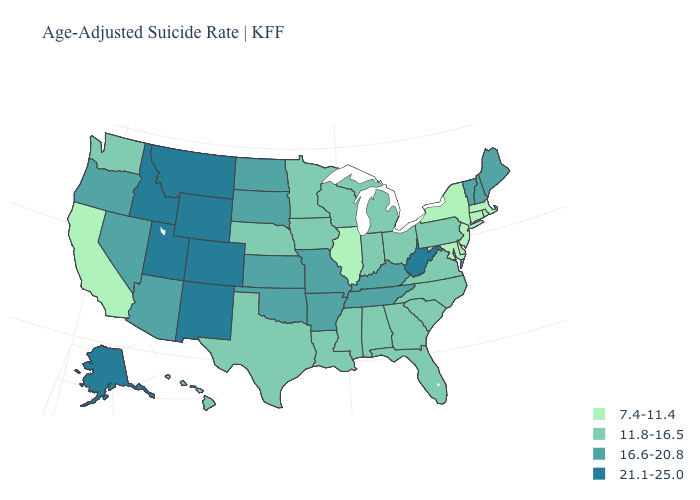Which states have the highest value in the USA?
Keep it brief. Alaska, Colorado, Idaho, Montana, New Mexico, Utah, West Virginia, Wyoming. How many symbols are there in the legend?
Short answer required. 4. What is the value of Mississippi?
Give a very brief answer. 11.8-16.5. Name the states that have a value in the range 16.6-20.8?
Write a very short answer. Arizona, Arkansas, Kansas, Kentucky, Maine, Missouri, Nevada, New Hampshire, North Dakota, Oklahoma, Oregon, South Dakota, Tennessee, Vermont. Name the states that have a value in the range 11.8-16.5?
Be succinct. Alabama, Florida, Georgia, Hawaii, Indiana, Iowa, Louisiana, Michigan, Minnesota, Mississippi, Nebraska, North Carolina, Ohio, Pennsylvania, South Carolina, Texas, Virginia, Washington, Wisconsin. Does the first symbol in the legend represent the smallest category?
Concise answer only. Yes. Does Michigan have the highest value in the MidWest?
Give a very brief answer. No. Does Arizona have the highest value in the West?
Answer briefly. No. Does Illinois have the highest value in the USA?
Keep it brief. No. Is the legend a continuous bar?
Keep it brief. No. Which states have the lowest value in the Northeast?
Answer briefly. Connecticut, Massachusetts, New Jersey, New York, Rhode Island. What is the lowest value in the USA?
Concise answer only. 7.4-11.4. What is the value of Arizona?
Quick response, please. 16.6-20.8. Name the states that have a value in the range 21.1-25.0?
Be succinct. Alaska, Colorado, Idaho, Montana, New Mexico, Utah, West Virginia, Wyoming. Name the states that have a value in the range 11.8-16.5?
Keep it brief. Alabama, Florida, Georgia, Hawaii, Indiana, Iowa, Louisiana, Michigan, Minnesota, Mississippi, Nebraska, North Carolina, Ohio, Pennsylvania, South Carolina, Texas, Virginia, Washington, Wisconsin. 